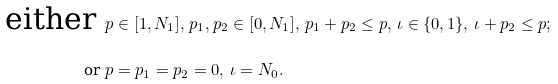Convert formula to latex. <formula><loc_0><loc_0><loc_500><loc_500>\text { either } & p \in [ 1 , N _ { 1 } ] , \, p _ { 1 } , p _ { 2 } \in [ 0 , N _ { 1 } ] , \, p _ { 1 } + p _ { 2 } \leq p , \, \iota \in \{ 0 , 1 \} , \, \iota + p _ { 2 } \leq p ; \\ \text { or } & p = p _ { 1 } = p _ { 2 } = 0 , \, \iota = N _ { 0 } .</formula> 